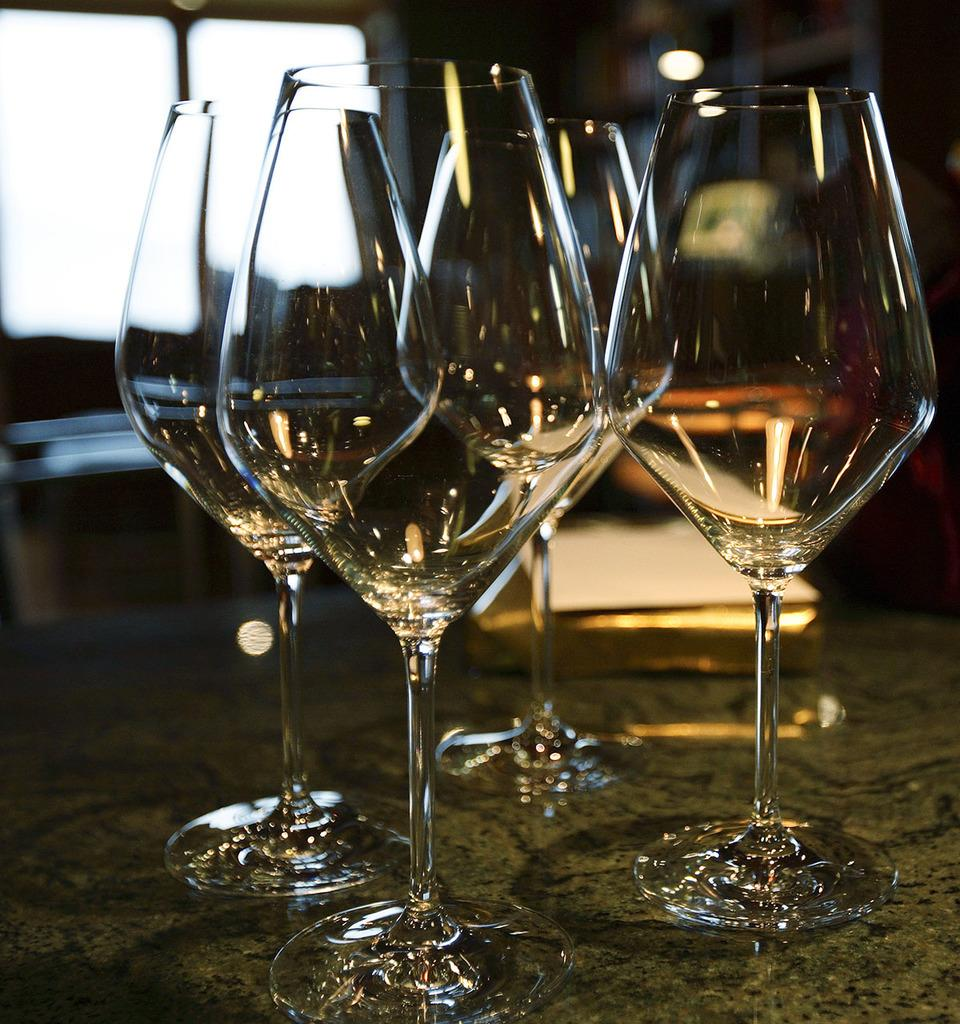What type of glasses are present in the image? There are wine glasses in the image. Can you describe the light visible at the top of the image? There is a light visible at the top of the image, but its specific characteristics are not mentioned in the provided facts. How many apples are hanging from the thread in the image? There is no thread or apples present in the image. What type of battle is depicted in the image? There is no battle depicted in the image. 